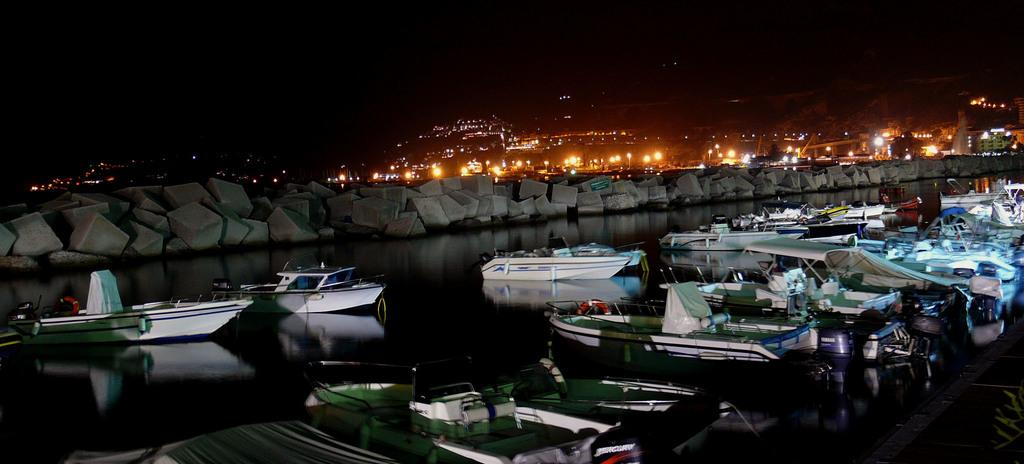What is on the water in the image? There are boats on the water in the image. What else can be seen in the image besides the boats? There are rocks, lights, and buildings in the image. Can you describe the lighting in the image? There are lights in the image. How would you describe the background of the image? The background of the image is dark. Are there any giants visible in the image? No, there are no giants present in the image. Can you tell me if there was an earthquake in the area depicted in the image? There is no information about an earthquake in the image or the surrounding area. 